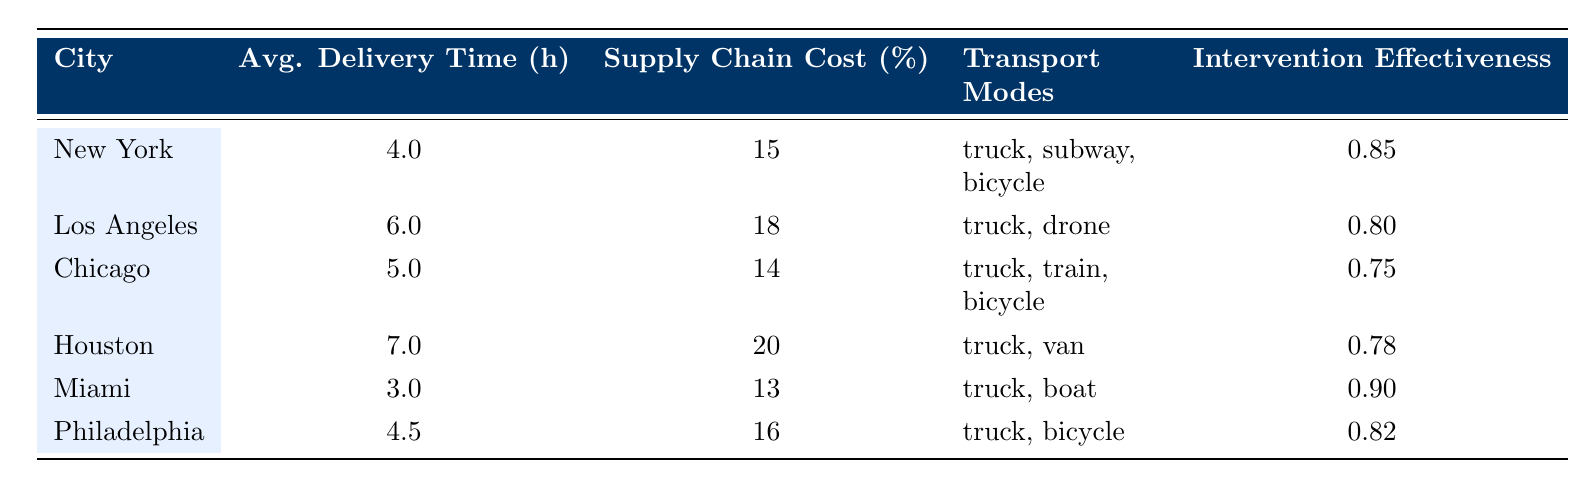What is the average delivery time in Miami? From the table, the average delivery time for Miami is listed as 3 hours.
Answer: 3 hours Which city has the highest supply chain cost percentage? By reviewing the supply chain cost percentage column, Houston has the highest value at 20%.
Answer: Houston What are the available transportation modes in Chicago? The table shows that Chicago has truck, train, and bicycle as the available transportation modes.
Answer: Truck, train, bicycle What is the median average delivery time across all cities? The average delivery times are: 4, 6, 5, 7, 3, and 4.5. Arranging these gives: 3, 4, 4, 5, 6, 7. The median is the average of the 3rd and 4th numbers, which is (4 + 5) / 2 = 4.5 hours.
Answer: 4.5 hours Is there a city that has both an average delivery time under 5 hours and a supply chain cost percentage under 15%? Examining the table, Miami has an average delivery time of 3 hours and a supply chain cost of 13%. Only Miami meets both criteria.
Answer: Yes Which city has the lowest intervention effectiveness index? Looking at the intervention effectiveness index column, Chicago has the lowest value of 0.75.
Answer: Chicago Calculate the average supply chain cost percentage for all cities. Adding the supply chain costs: 15 + 18 + 14 + 20 + 13 + 16 = 96. There are 6 cities, so the average is 96 / 6 = 16%.
Answer: 16% What is the combined average delivery time for New York and Philadelphia? The average delivery times for New York and Philadelphia are 4 and 4.5 hours respectively. Their combined average is (4 + 4.5) / 2 = 4.25 hours.
Answer: 4.25 hours In which cities is the intervention effectiveness index above 0.80? Reviewing the index, Miami (0.90), New York (0.85), and Philadelphia (0.82) all have values above 0.80.
Answer: Miami, New York, Philadelphia 